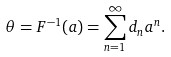Convert formula to latex. <formula><loc_0><loc_0><loc_500><loc_500>\theta = F ^ { - 1 } ( a ) = \sum _ { n = 1 } ^ { \infty } d _ { n } { a } ^ { n } .</formula> 